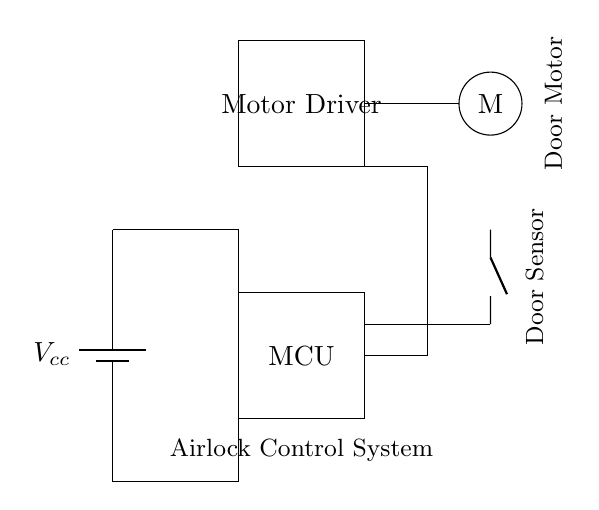What is the main component responsible for controlling the door? The Motor Driver is responsible for controlling the door's movement, receiving signals from the Microcontroller to operate the Door Motor.
Answer: Motor Driver What does the acronym MCU stand for in this circuit? MCU stands for Microcontroller Unit, which is the component that processes inputs from the Door Sensor and sends commands to the Motor Driver.
Answer: Microcontroller Unit How many main components are shown in this circuit? The circuit diagram includes four main components: the Power Supply, Microcontroller, Motor Driver, and Door Motor.
Answer: Four What type of sensor is used in this circuit for the door? The circuit features a Door Sensor, which detects whether the door is open or closed and informs the Microcontroller to control the Motor Driver accordingly.
Answer: Door Sensor Which component receives power from the Battery? The Power Supply (battery) provides voltage to the entire circuit, including the Microcontroller and Motor Driver, enabling their functions.
Answer: Power Supply What is the purpose of the connections shown in the circuit? The connections interlink the components, allowing the flow of signals and power essential for the operation of the door control system.
Answer: Interlinking components What does the presence of a circle denote in the circuit? In circuit diagrams, a circle usually represents a rotating component; here, it indicates the Door Motor which physically opens and closes the door.
Answer: Door Motor 